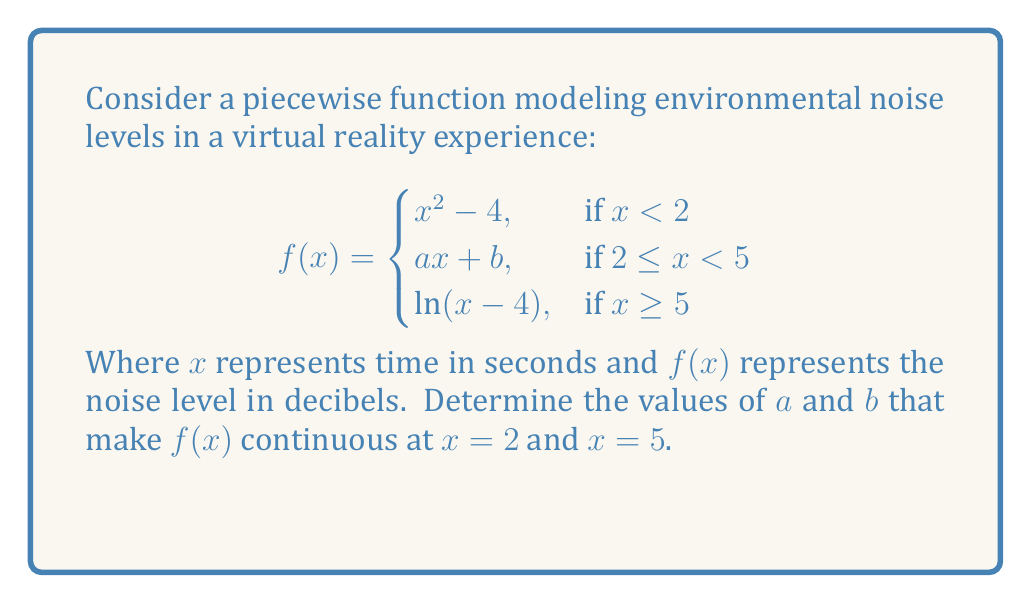Give your solution to this math problem. To determine the values of $a$ and $b$ that make $f(x)$ continuous, we need to ensure that the function is continuous at $x = 2$ and $x = 5$. For a function to be continuous at a point, the limit from both sides must exist and be equal to the function value at that point.

1. Continuity at $x = 2$:
   
   Left limit: $\lim_{x \to 2^-} f(x) = 2^2 - 4 = 0$
   Right limit: $\lim_{x \to 2^+} f(x) = a(2) + b = 2a + b$
   
   For continuity: $0 = 2a + b$ ... (Equation 1)

2. Continuity at $x = 5$:
   
   Left limit: $\lim_{x \to 5^-} f(x) = 5a + b$
   Right limit: $\lim_{x \to 5^+} f(x) = \ln(5-4) = \ln(1) = 0$
   
   For continuity: $5a + b = 0$ ... (Equation 2)

3. Solve the system of equations:
   
   Equation 1: $0 = 2a + b$
   Equation 2: $0 = 5a + b$
   
   Subtracting Equation 1 from Equation 2:
   $0 = 3a$
   $a = 0$
   
   Substituting $a = 0$ into Equation 1:
   $0 = 2(0) + b$
   $b = 0$

Therefore, $a = 0$ and $b = 0$ make $f(x)$ continuous at both $x = 2$ and $x = 5$.
Answer: $a = 0, b = 0$ 